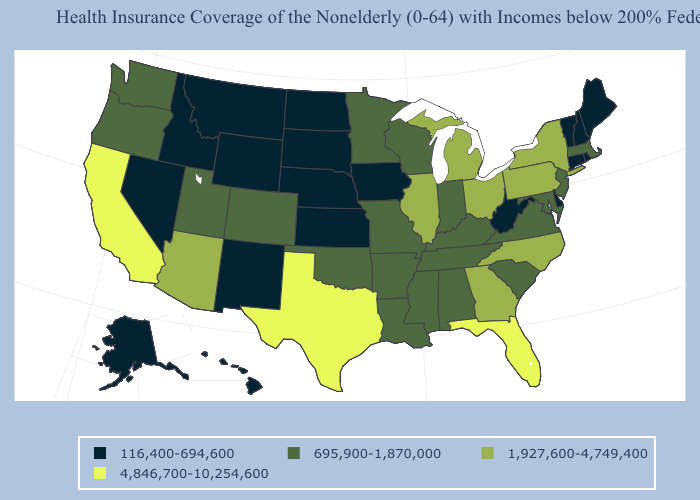What is the value of Delaware?
Write a very short answer. 116,400-694,600. Does Idaho have a higher value than Florida?
Write a very short answer. No. Name the states that have a value in the range 116,400-694,600?
Quick response, please. Alaska, Connecticut, Delaware, Hawaii, Idaho, Iowa, Kansas, Maine, Montana, Nebraska, Nevada, New Hampshire, New Mexico, North Dakota, Rhode Island, South Dakota, Vermont, West Virginia, Wyoming. What is the highest value in states that border New Hampshire?
Be succinct. 695,900-1,870,000. What is the highest value in states that border New Hampshire?
Answer briefly. 695,900-1,870,000. Does Rhode Island have the lowest value in the Northeast?
Write a very short answer. Yes. Does the map have missing data?
Answer briefly. No. Does Massachusetts have a lower value than Virginia?
Concise answer only. No. Name the states that have a value in the range 4,846,700-10,254,600?
Concise answer only. California, Florida, Texas. How many symbols are there in the legend?
Keep it brief. 4. Name the states that have a value in the range 1,927,600-4,749,400?
Quick response, please. Arizona, Georgia, Illinois, Michigan, New York, North Carolina, Ohio, Pennsylvania. Name the states that have a value in the range 695,900-1,870,000?
Give a very brief answer. Alabama, Arkansas, Colorado, Indiana, Kentucky, Louisiana, Maryland, Massachusetts, Minnesota, Mississippi, Missouri, New Jersey, Oklahoma, Oregon, South Carolina, Tennessee, Utah, Virginia, Washington, Wisconsin. Which states have the lowest value in the USA?
Give a very brief answer. Alaska, Connecticut, Delaware, Hawaii, Idaho, Iowa, Kansas, Maine, Montana, Nebraska, Nevada, New Hampshire, New Mexico, North Dakota, Rhode Island, South Dakota, Vermont, West Virginia, Wyoming. Among the states that border Missouri , does Oklahoma have the lowest value?
Short answer required. No. Which states have the highest value in the USA?
Keep it brief. California, Florida, Texas. 